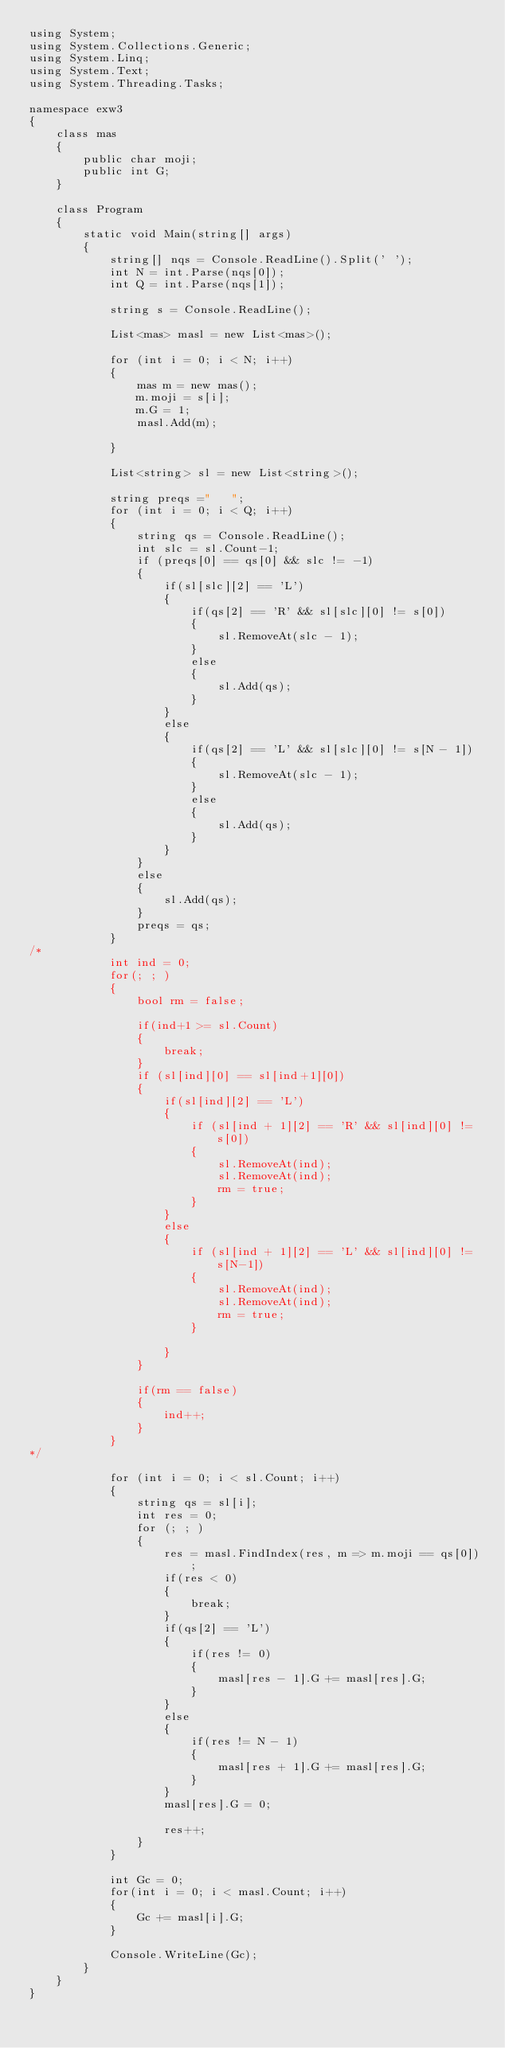Convert code to text. <code><loc_0><loc_0><loc_500><loc_500><_C#_>using System;
using System.Collections.Generic;
using System.Linq;
using System.Text;
using System.Threading.Tasks;

namespace exw3
{
    class mas
    {
        public char moji;
        public int G;
    }

    class Program
    {
        static void Main(string[] args)
        {
            string[] nqs = Console.ReadLine().Split(' ');
            int N = int.Parse(nqs[0]);
            int Q = int.Parse(nqs[1]);

            string s = Console.ReadLine();

            List<mas> masl = new List<mas>();

            for (int i = 0; i < N; i++)
            {
                mas m = new mas();
                m.moji = s[i];
                m.G = 1;
                masl.Add(m);

            }

            List<string> sl = new List<string>();

            string preqs ="   ";
            for (int i = 0; i < Q; i++)
            {
                string qs = Console.ReadLine();
                int slc = sl.Count-1;
                if (preqs[0] == qs[0] && slc != -1)
                {
                    if(sl[slc][2] == 'L')
                    {
                        if(qs[2] == 'R' && sl[slc][0] != s[0])
                        {
                            sl.RemoveAt(slc - 1);
                        }
                        else
                        {
                            sl.Add(qs);
                        }
                    }
                    else
                    {
                        if(qs[2] == 'L' && sl[slc][0] != s[N - 1])
                        {
                            sl.RemoveAt(slc - 1);
                        }
                        else
                        {
                            sl.Add(qs);
                        }
                    }
                }
                else
                {
                    sl.Add(qs);
                }
                preqs = qs;
            }
/*
            int ind = 0;
            for(; ; )
            {
                bool rm = false;

                if(ind+1 >= sl.Count)
                {
                    break;
                }
                if (sl[ind][0] == sl[ind+1][0])
                {
                    if(sl[ind][2] == 'L')
                    {
                        if (sl[ind + 1][2] == 'R' && sl[ind][0] != s[0])
                        {
                            sl.RemoveAt(ind);
                            sl.RemoveAt(ind);
                            rm = true;
                        }
                    }
                    else
                    {
                        if (sl[ind + 1][2] == 'L' && sl[ind][0] != s[N-1])
                        {
                            sl.RemoveAt(ind);
                            sl.RemoveAt(ind);
                            rm = true;
                        }

                    }
                }

                if(rm == false)
                {
                    ind++;
                }
            }
*/

            for (int i = 0; i < sl.Count; i++)
            {
                string qs = sl[i];
                int res = 0;
                for (; ; )
                {
                    res = masl.FindIndex(res, m => m.moji == qs[0]);
                    if(res < 0)
                    {
                        break;
                    }
                    if(qs[2] == 'L')
                    {
                        if(res != 0)
                        {
                            masl[res - 1].G += masl[res].G;
                        }
                    }
                    else
                    {
                        if(res != N - 1)
                        {
                            masl[res + 1].G += masl[res].G;
                        }
                    }
                    masl[res].G = 0;

                    res++;
                }
            }

            int Gc = 0;
            for(int i = 0; i < masl.Count; i++)
            {
                Gc += masl[i].G;
            }

            Console.WriteLine(Gc);
        }
    }
}
</code> 